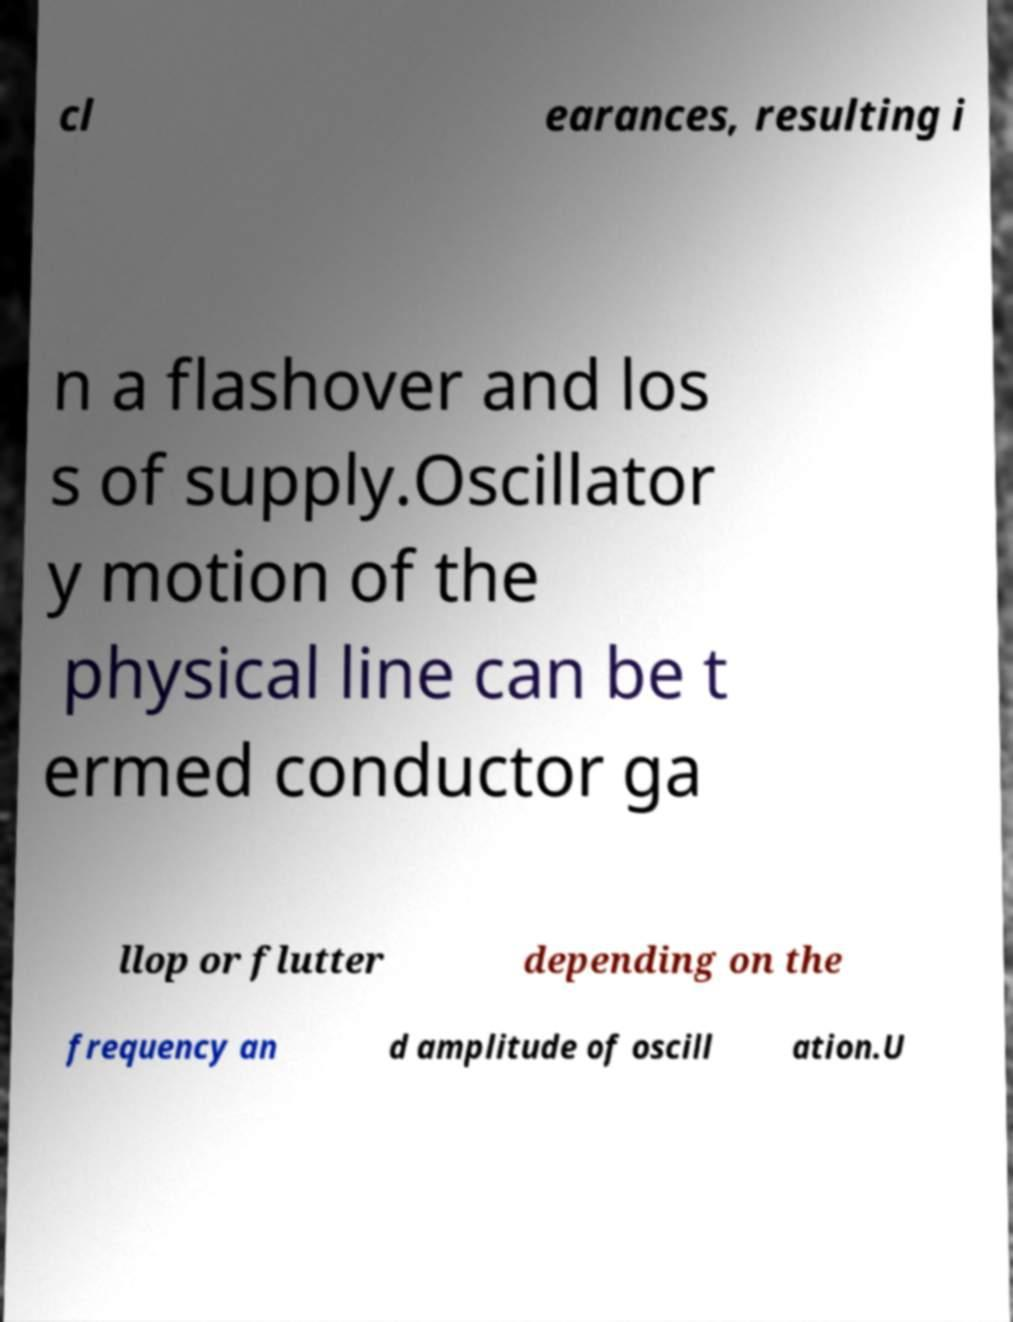Please identify and transcribe the text found in this image. cl earances, resulting i n a flashover and los s of supply.Oscillator y motion of the physical line can be t ermed conductor ga llop or flutter depending on the frequency an d amplitude of oscill ation.U 